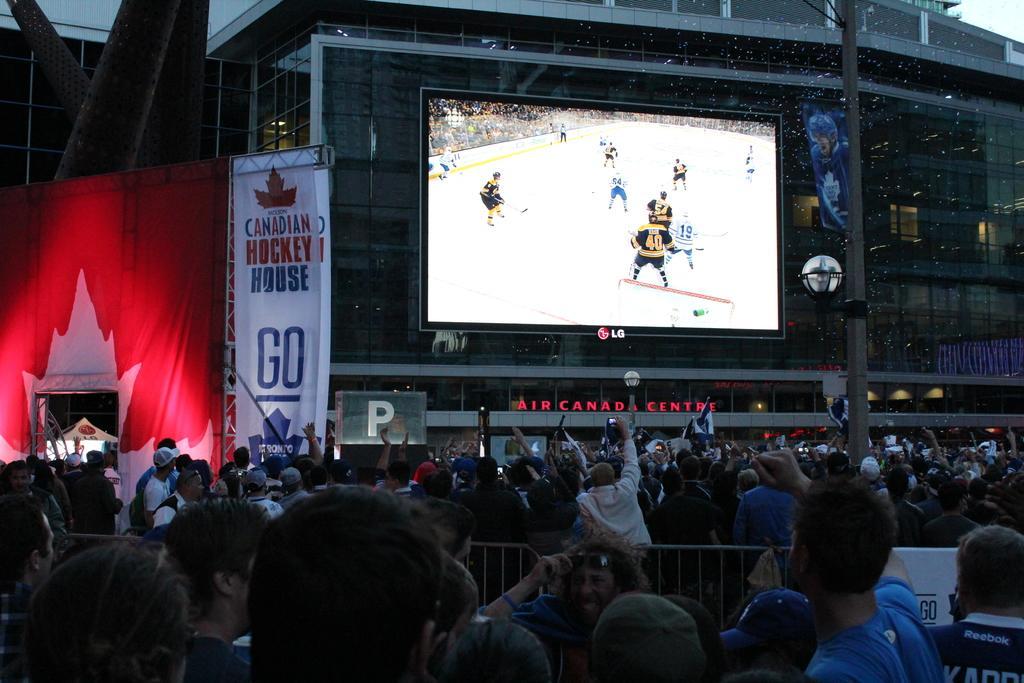In one or two sentences, can you explain what this image depicts? In the foreground I can see a crowd on the road and fence. In the background I can see a screen, buildings, poster and the sky. This image is taken on the street. 